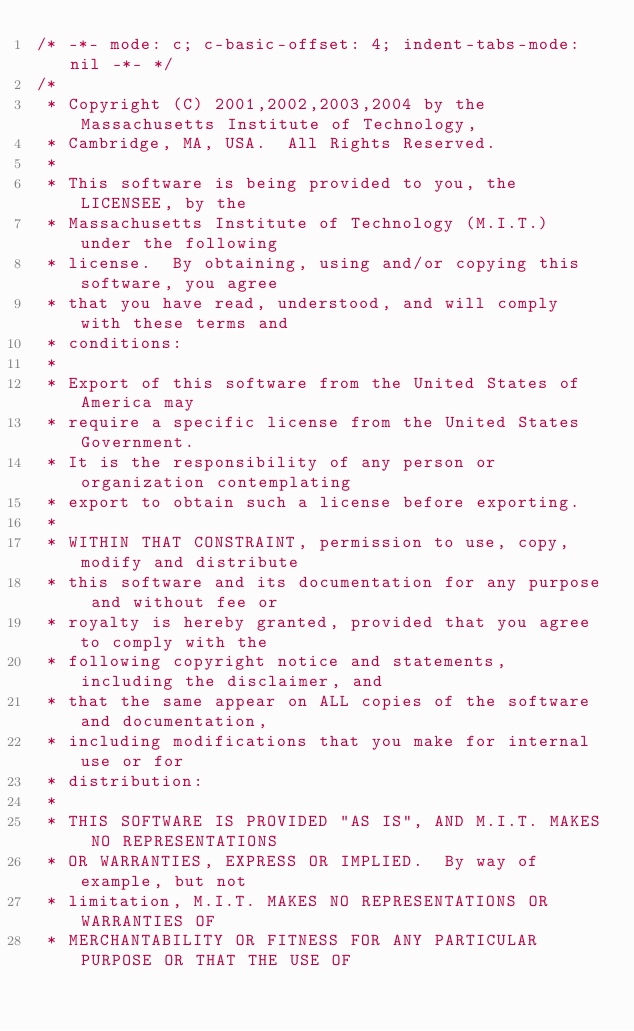<code> <loc_0><loc_0><loc_500><loc_500><_C_>/* -*- mode: c; c-basic-offset: 4; indent-tabs-mode: nil -*- */
/*
 * Copyright (C) 2001,2002,2003,2004 by the Massachusetts Institute of Technology,
 * Cambridge, MA, USA.  All Rights Reserved.
 *
 * This software is being provided to you, the LICENSEE, by the
 * Massachusetts Institute of Technology (M.I.T.) under the following
 * license.  By obtaining, using and/or copying this software, you agree
 * that you have read, understood, and will comply with these terms and
 * conditions:
 *
 * Export of this software from the United States of America may
 * require a specific license from the United States Government.
 * It is the responsibility of any person or organization contemplating
 * export to obtain such a license before exporting.
 *
 * WITHIN THAT CONSTRAINT, permission to use, copy, modify and distribute
 * this software and its documentation for any purpose and without fee or
 * royalty is hereby granted, provided that you agree to comply with the
 * following copyright notice and statements, including the disclaimer, and
 * that the same appear on ALL copies of the software and documentation,
 * including modifications that you make for internal use or for
 * distribution:
 *
 * THIS SOFTWARE IS PROVIDED "AS IS", AND M.I.T. MAKES NO REPRESENTATIONS
 * OR WARRANTIES, EXPRESS OR IMPLIED.  By way of example, but not
 * limitation, M.I.T. MAKES NO REPRESENTATIONS OR WARRANTIES OF
 * MERCHANTABILITY OR FITNESS FOR ANY PARTICULAR PURPOSE OR THAT THE USE OF</code> 